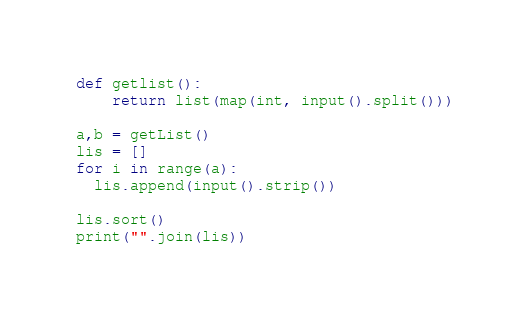Convert code to text. <code><loc_0><loc_0><loc_500><loc_500><_Python_>def getlist():
    return list(map(int, input().split()))
  
a,b = getList()
lis = []
for i in range(a):
  lis.append(input().strip())
  
lis.sort()
print("".join(lis))</code> 